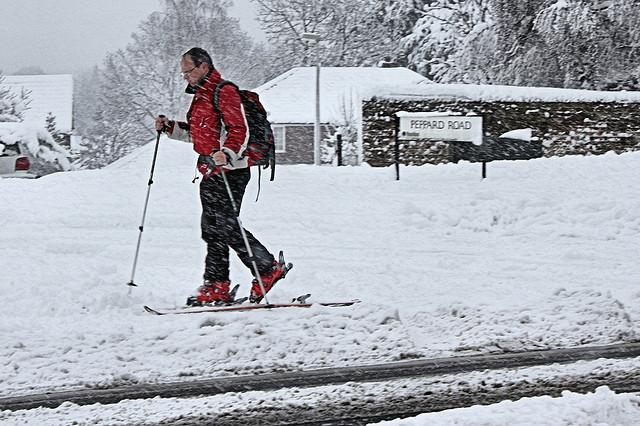What caused the lines in the snow? Please explain your reasoning. car wheels. The car wheels cause the lines. 